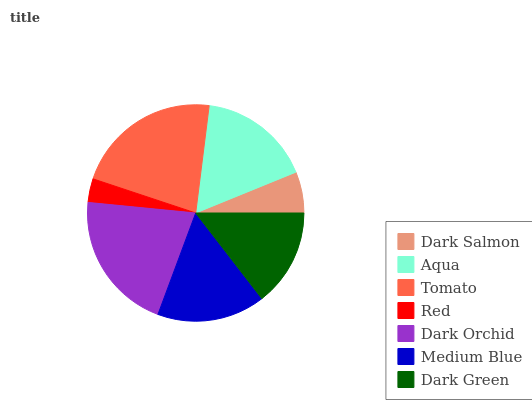Is Red the minimum?
Answer yes or no. Yes. Is Tomato the maximum?
Answer yes or no. Yes. Is Aqua the minimum?
Answer yes or no. No. Is Aqua the maximum?
Answer yes or no. No. Is Aqua greater than Dark Salmon?
Answer yes or no. Yes. Is Dark Salmon less than Aqua?
Answer yes or no. Yes. Is Dark Salmon greater than Aqua?
Answer yes or no. No. Is Aqua less than Dark Salmon?
Answer yes or no. No. Is Medium Blue the high median?
Answer yes or no. Yes. Is Medium Blue the low median?
Answer yes or no. Yes. Is Dark Green the high median?
Answer yes or no. No. Is Dark Salmon the low median?
Answer yes or no. No. 